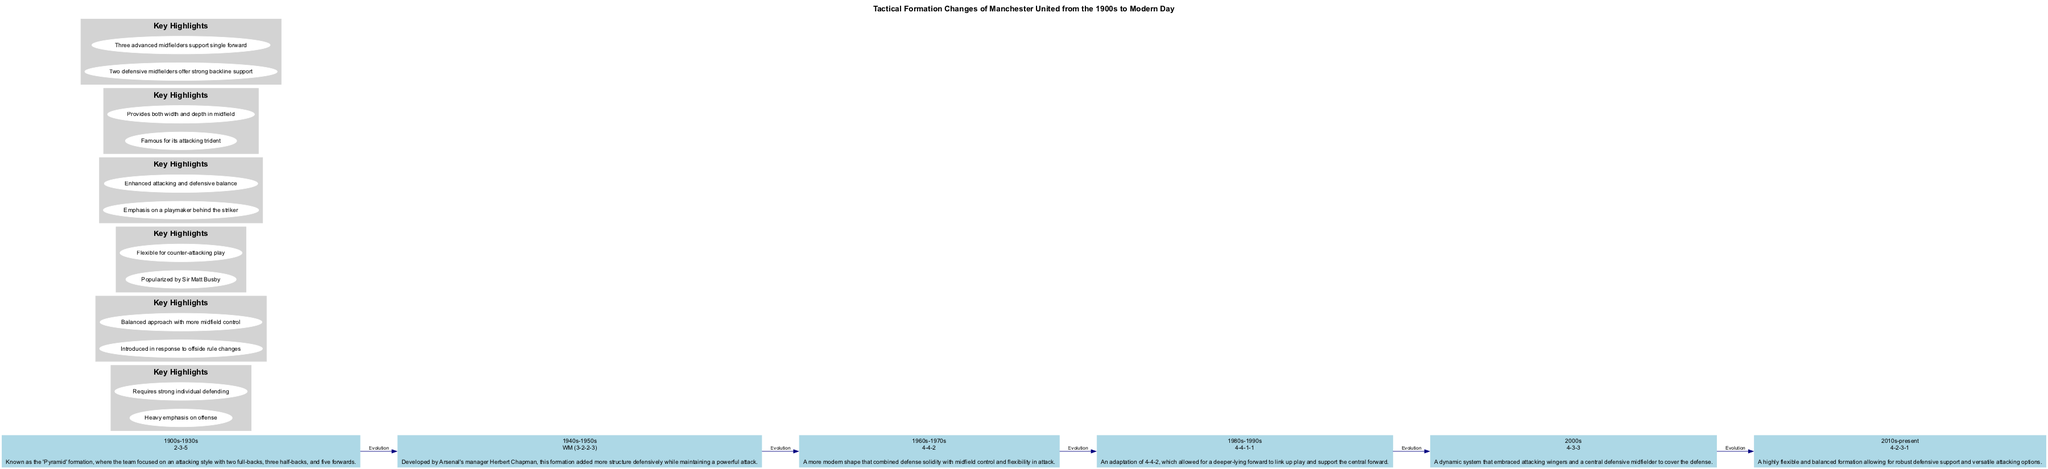What formation was used by Manchester United during the 1900s to 1930s? The diagram identifies the time period of 1900s to 1930s specifically showing the formation used during that era is "2-3-5".
Answer: 2-3-5 What is the key highlight of the WM (3-2-2-3) formation? By examining the box listing the highlights for the WM formation, one can see that one of the key highlights is that it was "Introduced in response to offside rule changes".
Answer: Introduced in response to offside rule changes How many total formations are displayed in the diagram? The diagram contains six nodes, each representing a different formation over the years, thus we can count to determine that there are six formations shown.
Answer: 6 Which formation allowed for a deeper-lying forward? Looking through the nodes, the description for the formation in the 1980s-1990s states that it is an adaptation of 4-4-2 meant for a "deeper-lying forward to link up play".
Answer: 4-4-1-1 What is the main strategy of the 4-2-3-1 formation in the 2010s to present? The diagram indicates in the description of the 4-2-3-1 formation that it allows for "robust defensive support and versatile attacking options", summarizing the main strategy.
Answer: Robust defensive support and versatile attacking options What does the graph illustrate about the evolution of Manchester United's tactics over time? By reviewing the connections marked as "Evolution" from each node to the next, the diagram illustrates a chronological progression of tactical formations, showing how strategies have changed over the decades.
Answer: Chronological progression of tactical formations 